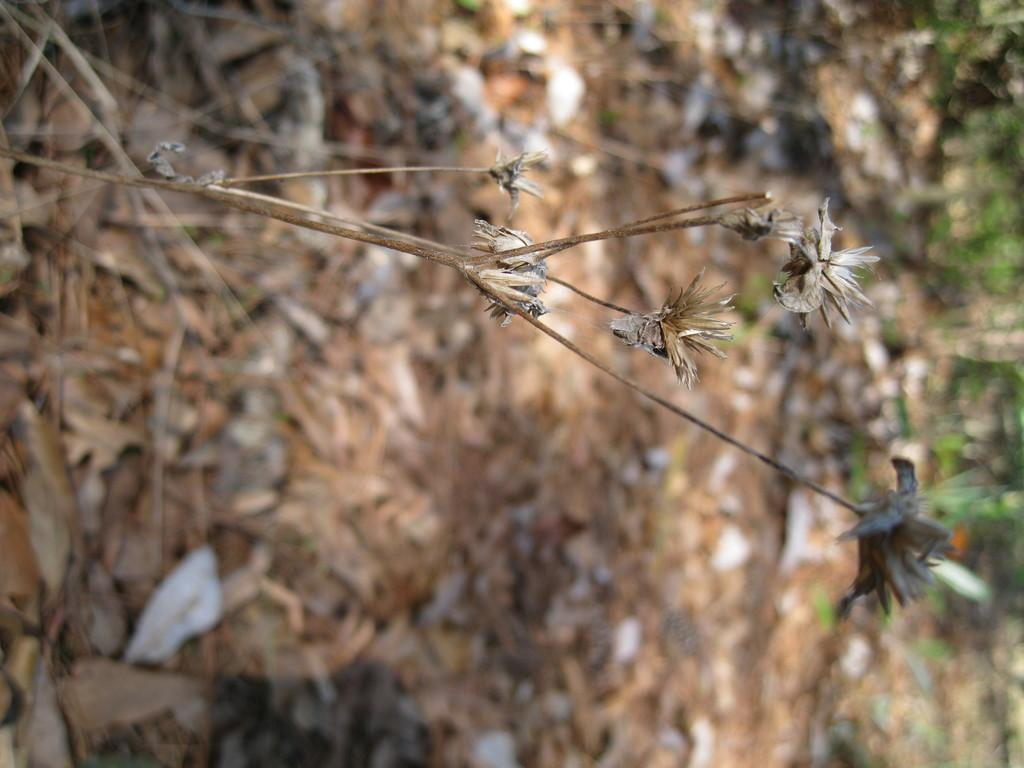What type of plant is in the image? There is a dried plant in the image. What can be observed about the flowers on the plant? The dried plant has dried flowers. Can you describe the background of the image? The background of the image is blurred. How many beds can be seen in the image? There are no beds present in the image. 